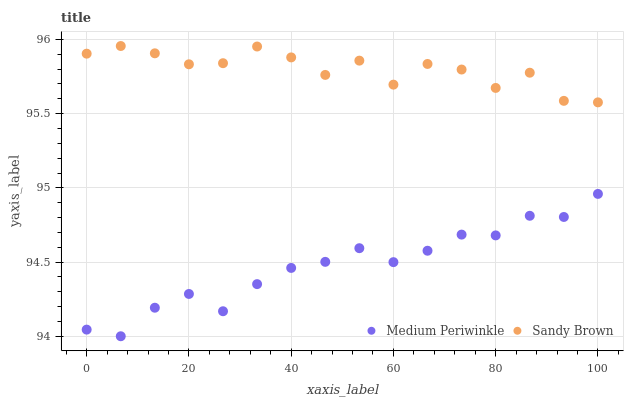Does Medium Periwinkle have the minimum area under the curve?
Answer yes or no. Yes. Does Sandy Brown have the maximum area under the curve?
Answer yes or no. Yes. Does Medium Periwinkle have the maximum area under the curve?
Answer yes or no. No. Is Medium Periwinkle the smoothest?
Answer yes or no. Yes. Is Sandy Brown the roughest?
Answer yes or no. Yes. Is Medium Periwinkle the roughest?
Answer yes or no. No. Does Medium Periwinkle have the lowest value?
Answer yes or no. Yes. Does Sandy Brown have the highest value?
Answer yes or no. Yes. Does Medium Periwinkle have the highest value?
Answer yes or no. No. Is Medium Periwinkle less than Sandy Brown?
Answer yes or no. Yes. Is Sandy Brown greater than Medium Periwinkle?
Answer yes or no. Yes. Does Medium Periwinkle intersect Sandy Brown?
Answer yes or no. No. 